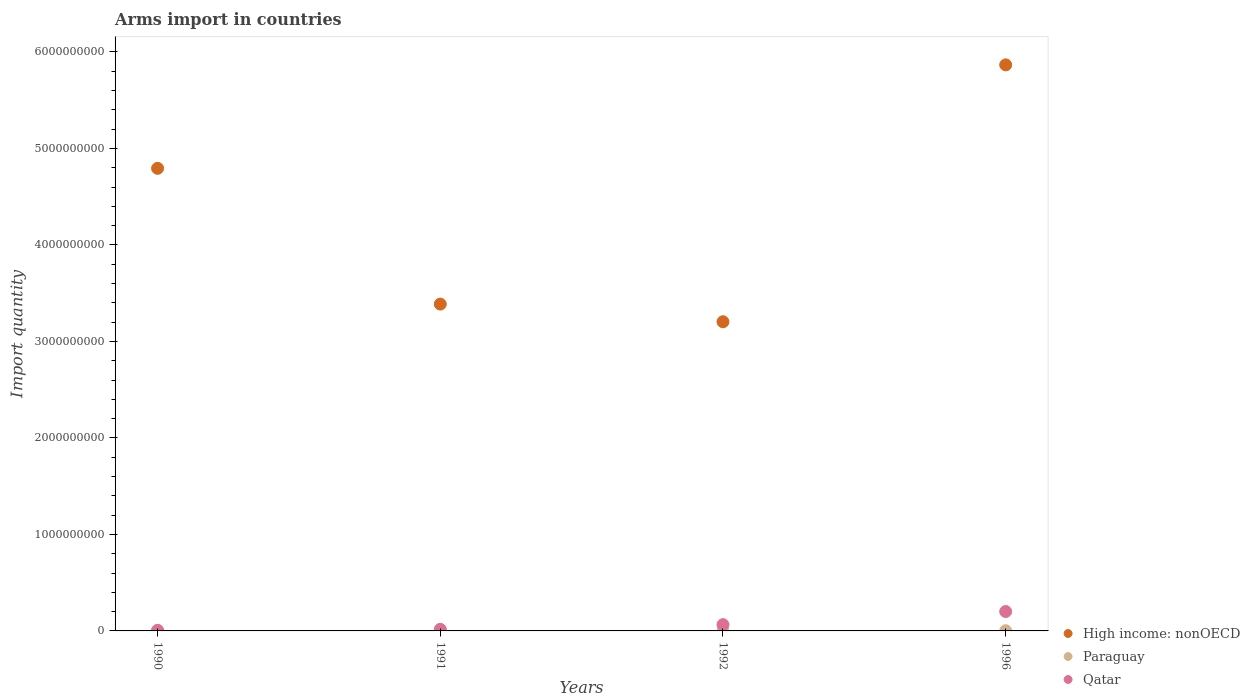How many different coloured dotlines are there?
Offer a very short reply. 3. What is the total arms import in Paraguay in 1991?
Offer a terse response. 3.00e+06. Across all years, what is the minimum total arms import in Qatar?
Keep it short and to the point. 5.00e+06. What is the total total arms import in Paraguay in the graph?
Give a very brief answer. 1.20e+07. What is the difference between the total arms import in Qatar in 1992 and the total arms import in High income: nonOECD in 1990?
Give a very brief answer. -4.73e+09. What is the average total arms import in High income: nonOECD per year?
Provide a short and direct response. 4.31e+09. In the year 1990, what is the difference between the total arms import in High income: nonOECD and total arms import in Qatar?
Provide a short and direct response. 4.79e+09. What is the ratio of the total arms import in Qatar in 1990 to that in 1991?
Provide a succinct answer. 0.29. Is the difference between the total arms import in High income: nonOECD in 1990 and 1992 greater than the difference between the total arms import in Qatar in 1990 and 1992?
Offer a terse response. Yes. What is the difference between the highest and the second highest total arms import in Qatar?
Your response must be concise. 1.36e+08. What is the difference between the highest and the lowest total arms import in High income: nonOECD?
Provide a succinct answer. 2.66e+09. In how many years, is the total arms import in Qatar greater than the average total arms import in Qatar taken over all years?
Make the answer very short. 1. Is the total arms import in Qatar strictly greater than the total arms import in High income: nonOECD over the years?
Provide a short and direct response. No. Is the total arms import in High income: nonOECD strictly less than the total arms import in Paraguay over the years?
Your answer should be very brief. No. How many years are there in the graph?
Offer a terse response. 4. What is the difference between two consecutive major ticks on the Y-axis?
Make the answer very short. 1.00e+09. Are the values on the major ticks of Y-axis written in scientific E-notation?
Offer a very short reply. No. Does the graph contain any zero values?
Keep it short and to the point. No. Where does the legend appear in the graph?
Keep it short and to the point. Bottom right. How are the legend labels stacked?
Ensure brevity in your answer.  Vertical. What is the title of the graph?
Your answer should be compact. Arms import in countries. What is the label or title of the Y-axis?
Give a very brief answer. Import quantity. What is the Import quantity in High income: nonOECD in 1990?
Your answer should be very brief. 4.79e+09. What is the Import quantity in Qatar in 1990?
Your answer should be very brief. 5.00e+06. What is the Import quantity in High income: nonOECD in 1991?
Your answer should be very brief. 3.39e+09. What is the Import quantity in Paraguay in 1991?
Make the answer very short. 3.00e+06. What is the Import quantity in Qatar in 1991?
Keep it short and to the point. 1.70e+07. What is the Import quantity in High income: nonOECD in 1992?
Ensure brevity in your answer.  3.20e+09. What is the Import quantity in Paraguay in 1992?
Make the answer very short. 1.00e+06. What is the Import quantity in Qatar in 1992?
Offer a terse response. 6.50e+07. What is the Import quantity of High income: nonOECD in 1996?
Offer a terse response. 5.87e+09. What is the Import quantity in Paraguay in 1996?
Provide a succinct answer. 2.00e+06. What is the Import quantity in Qatar in 1996?
Keep it short and to the point. 2.01e+08. Across all years, what is the maximum Import quantity in High income: nonOECD?
Your response must be concise. 5.87e+09. Across all years, what is the maximum Import quantity of Paraguay?
Ensure brevity in your answer.  6.00e+06. Across all years, what is the maximum Import quantity in Qatar?
Offer a very short reply. 2.01e+08. Across all years, what is the minimum Import quantity of High income: nonOECD?
Keep it short and to the point. 3.20e+09. Across all years, what is the minimum Import quantity in Paraguay?
Provide a short and direct response. 1.00e+06. Across all years, what is the minimum Import quantity in Qatar?
Make the answer very short. 5.00e+06. What is the total Import quantity of High income: nonOECD in the graph?
Offer a terse response. 1.73e+1. What is the total Import quantity of Paraguay in the graph?
Your answer should be very brief. 1.20e+07. What is the total Import quantity in Qatar in the graph?
Ensure brevity in your answer.  2.88e+08. What is the difference between the Import quantity in High income: nonOECD in 1990 and that in 1991?
Provide a succinct answer. 1.41e+09. What is the difference between the Import quantity in Paraguay in 1990 and that in 1991?
Your response must be concise. 3.00e+06. What is the difference between the Import quantity of Qatar in 1990 and that in 1991?
Make the answer very short. -1.20e+07. What is the difference between the Import quantity of High income: nonOECD in 1990 and that in 1992?
Your response must be concise. 1.59e+09. What is the difference between the Import quantity of Qatar in 1990 and that in 1992?
Keep it short and to the point. -6.00e+07. What is the difference between the Import quantity in High income: nonOECD in 1990 and that in 1996?
Your response must be concise. -1.07e+09. What is the difference between the Import quantity in Qatar in 1990 and that in 1996?
Give a very brief answer. -1.96e+08. What is the difference between the Import quantity in High income: nonOECD in 1991 and that in 1992?
Your answer should be compact. 1.83e+08. What is the difference between the Import quantity of Qatar in 1991 and that in 1992?
Offer a terse response. -4.80e+07. What is the difference between the Import quantity of High income: nonOECD in 1991 and that in 1996?
Ensure brevity in your answer.  -2.48e+09. What is the difference between the Import quantity in Qatar in 1991 and that in 1996?
Provide a short and direct response. -1.84e+08. What is the difference between the Import quantity of High income: nonOECD in 1992 and that in 1996?
Give a very brief answer. -2.66e+09. What is the difference between the Import quantity in Qatar in 1992 and that in 1996?
Keep it short and to the point. -1.36e+08. What is the difference between the Import quantity of High income: nonOECD in 1990 and the Import quantity of Paraguay in 1991?
Provide a short and direct response. 4.79e+09. What is the difference between the Import quantity of High income: nonOECD in 1990 and the Import quantity of Qatar in 1991?
Ensure brevity in your answer.  4.78e+09. What is the difference between the Import quantity in Paraguay in 1990 and the Import quantity in Qatar in 1991?
Offer a terse response. -1.10e+07. What is the difference between the Import quantity of High income: nonOECD in 1990 and the Import quantity of Paraguay in 1992?
Your answer should be very brief. 4.79e+09. What is the difference between the Import quantity of High income: nonOECD in 1990 and the Import quantity of Qatar in 1992?
Ensure brevity in your answer.  4.73e+09. What is the difference between the Import quantity in Paraguay in 1990 and the Import quantity in Qatar in 1992?
Offer a terse response. -5.90e+07. What is the difference between the Import quantity in High income: nonOECD in 1990 and the Import quantity in Paraguay in 1996?
Make the answer very short. 4.79e+09. What is the difference between the Import quantity of High income: nonOECD in 1990 and the Import quantity of Qatar in 1996?
Make the answer very short. 4.59e+09. What is the difference between the Import quantity in Paraguay in 1990 and the Import quantity in Qatar in 1996?
Your response must be concise. -1.95e+08. What is the difference between the Import quantity of High income: nonOECD in 1991 and the Import quantity of Paraguay in 1992?
Your answer should be compact. 3.39e+09. What is the difference between the Import quantity in High income: nonOECD in 1991 and the Import quantity in Qatar in 1992?
Keep it short and to the point. 3.32e+09. What is the difference between the Import quantity in Paraguay in 1991 and the Import quantity in Qatar in 1992?
Your response must be concise. -6.20e+07. What is the difference between the Import quantity of High income: nonOECD in 1991 and the Import quantity of Paraguay in 1996?
Provide a short and direct response. 3.38e+09. What is the difference between the Import quantity in High income: nonOECD in 1991 and the Import quantity in Qatar in 1996?
Your answer should be compact. 3.19e+09. What is the difference between the Import quantity in Paraguay in 1991 and the Import quantity in Qatar in 1996?
Provide a short and direct response. -1.98e+08. What is the difference between the Import quantity of High income: nonOECD in 1992 and the Import quantity of Paraguay in 1996?
Give a very brief answer. 3.20e+09. What is the difference between the Import quantity of High income: nonOECD in 1992 and the Import quantity of Qatar in 1996?
Offer a very short reply. 3.00e+09. What is the difference between the Import quantity of Paraguay in 1992 and the Import quantity of Qatar in 1996?
Keep it short and to the point. -2.00e+08. What is the average Import quantity of High income: nonOECD per year?
Keep it short and to the point. 4.31e+09. What is the average Import quantity of Paraguay per year?
Keep it short and to the point. 3.00e+06. What is the average Import quantity of Qatar per year?
Provide a succinct answer. 7.20e+07. In the year 1990, what is the difference between the Import quantity of High income: nonOECD and Import quantity of Paraguay?
Keep it short and to the point. 4.79e+09. In the year 1990, what is the difference between the Import quantity of High income: nonOECD and Import quantity of Qatar?
Give a very brief answer. 4.79e+09. In the year 1991, what is the difference between the Import quantity of High income: nonOECD and Import quantity of Paraguay?
Make the answer very short. 3.38e+09. In the year 1991, what is the difference between the Import quantity in High income: nonOECD and Import quantity in Qatar?
Your response must be concise. 3.37e+09. In the year 1991, what is the difference between the Import quantity in Paraguay and Import quantity in Qatar?
Give a very brief answer. -1.40e+07. In the year 1992, what is the difference between the Import quantity of High income: nonOECD and Import quantity of Paraguay?
Your response must be concise. 3.20e+09. In the year 1992, what is the difference between the Import quantity in High income: nonOECD and Import quantity in Qatar?
Keep it short and to the point. 3.14e+09. In the year 1992, what is the difference between the Import quantity of Paraguay and Import quantity of Qatar?
Make the answer very short. -6.40e+07. In the year 1996, what is the difference between the Import quantity of High income: nonOECD and Import quantity of Paraguay?
Your answer should be compact. 5.86e+09. In the year 1996, what is the difference between the Import quantity in High income: nonOECD and Import quantity in Qatar?
Your answer should be very brief. 5.66e+09. In the year 1996, what is the difference between the Import quantity of Paraguay and Import quantity of Qatar?
Give a very brief answer. -1.99e+08. What is the ratio of the Import quantity of High income: nonOECD in 1990 to that in 1991?
Provide a short and direct response. 1.42. What is the ratio of the Import quantity in Qatar in 1990 to that in 1991?
Your answer should be compact. 0.29. What is the ratio of the Import quantity in High income: nonOECD in 1990 to that in 1992?
Offer a terse response. 1.5. What is the ratio of the Import quantity of Paraguay in 1990 to that in 1992?
Your answer should be very brief. 6. What is the ratio of the Import quantity in Qatar in 1990 to that in 1992?
Offer a very short reply. 0.08. What is the ratio of the Import quantity in High income: nonOECD in 1990 to that in 1996?
Offer a very short reply. 0.82. What is the ratio of the Import quantity in Qatar in 1990 to that in 1996?
Give a very brief answer. 0.02. What is the ratio of the Import quantity in High income: nonOECD in 1991 to that in 1992?
Offer a terse response. 1.06. What is the ratio of the Import quantity of Paraguay in 1991 to that in 1992?
Offer a very short reply. 3. What is the ratio of the Import quantity in Qatar in 1991 to that in 1992?
Your response must be concise. 0.26. What is the ratio of the Import quantity of High income: nonOECD in 1991 to that in 1996?
Ensure brevity in your answer.  0.58. What is the ratio of the Import quantity in Qatar in 1991 to that in 1996?
Keep it short and to the point. 0.08. What is the ratio of the Import quantity in High income: nonOECD in 1992 to that in 1996?
Ensure brevity in your answer.  0.55. What is the ratio of the Import quantity of Paraguay in 1992 to that in 1996?
Offer a very short reply. 0.5. What is the ratio of the Import quantity in Qatar in 1992 to that in 1996?
Keep it short and to the point. 0.32. What is the difference between the highest and the second highest Import quantity of High income: nonOECD?
Offer a very short reply. 1.07e+09. What is the difference between the highest and the second highest Import quantity in Paraguay?
Your answer should be compact. 3.00e+06. What is the difference between the highest and the second highest Import quantity of Qatar?
Offer a very short reply. 1.36e+08. What is the difference between the highest and the lowest Import quantity of High income: nonOECD?
Make the answer very short. 2.66e+09. What is the difference between the highest and the lowest Import quantity of Paraguay?
Keep it short and to the point. 5.00e+06. What is the difference between the highest and the lowest Import quantity of Qatar?
Offer a terse response. 1.96e+08. 